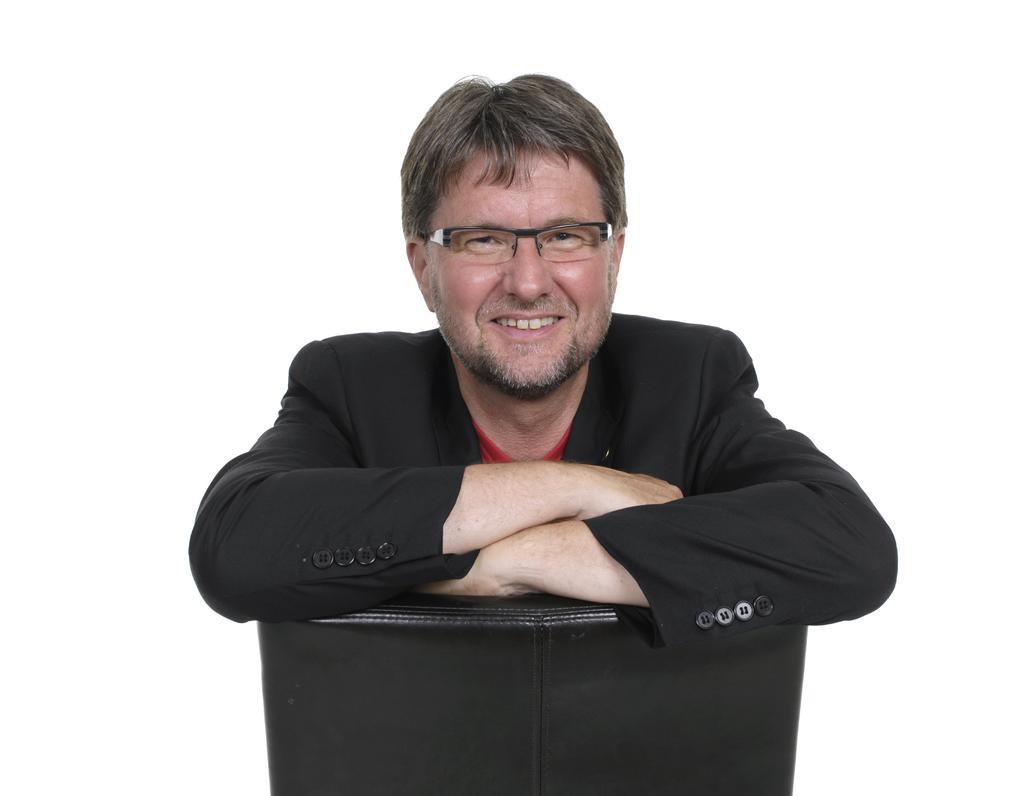Please provide a concise description of this image. In this image a man is sitting and smiling, he wore black color coat. 